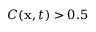Convert formula to latex. <formula><loc_0><loc_0><loc_500><loc_500>C ( { x } , t ) > 0 . 5</formula> 